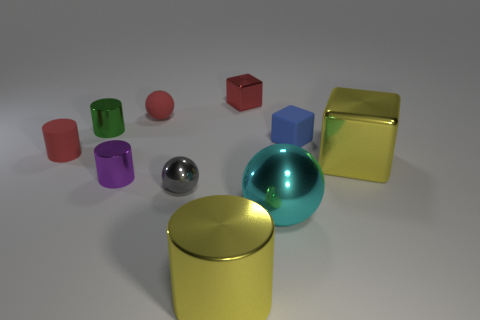Subtract all balls. How many objects are left? 7 Add 2 small blue matte cubes. How many small blue matte cubes are left? 3 Add 7 metal balls. How many metal balls exist? 9 Subtract 1 red spheres. How many objects are left? 9 Subtract all gray metallic things. Subtract all yellow cylinders. How many objects are left? 8 